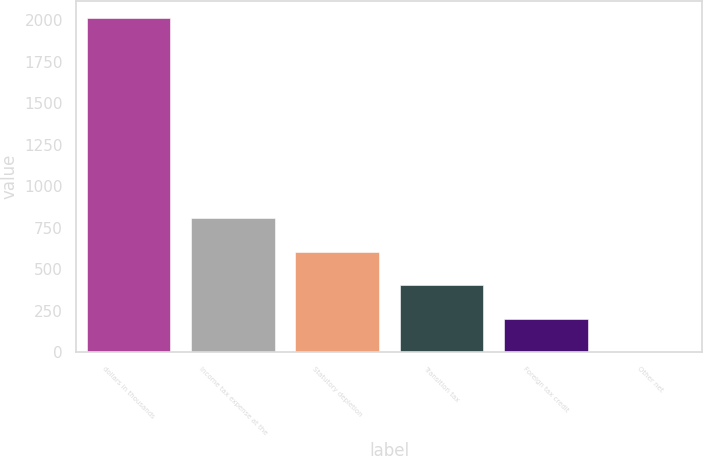Convert chart. <chart><loc_0><loc_0><loc_500><loc_500><bar_chart><fcel>dollars in thousands<fcel>Income tax expense at the<fcel>Statutory depletion<fcel>Transition tax<fcel>Foreign tax credit<fcel>Other net<nl><fcel>2016<fcel>806.76<fcel>605.22<fcel>403.68<fcel>202.14<fcel>0.6<nl></chart> 